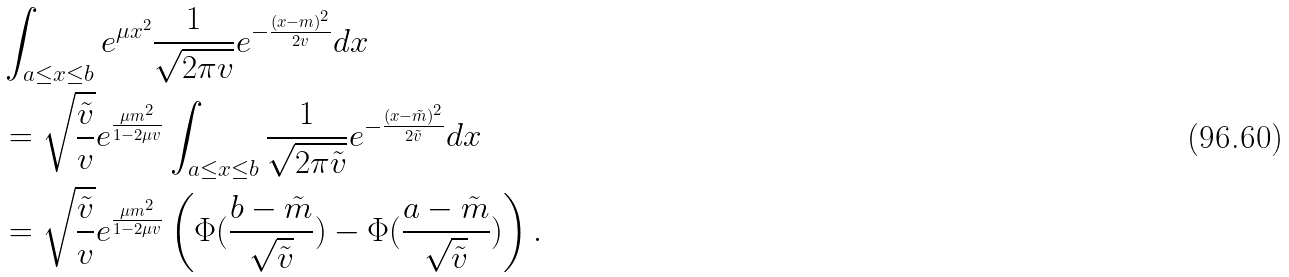Convert formula to latex. <formula><loc_0><loc_0><loc_500><loc_500>& \int _ { a \leq x \leq b } e ^ { \mu x ^ { 2 } } \frac { 1 } { \sqrt { 2 \pi v } } e ^ { - \frac { ( x - m ) ^ { 2 } } { 2 v } } d x \\ & = \sqrt { \frac { \tilde { v } } { v } } e ^ { \frac { \mu m ^ { 2 } } { 1 - 2 \mu v } } \int _ { a \leq x \leq b } \frac { 1 } { \sqrt { 2 \pi \tilde { v } } } e ^ { - \frac { ( x - \tilde { m } ) ^ { 2 } } { 2 \tilde { v } } } d x \\ & = \sqrt { \frac { \tilde { v } } { v } } e ^ { \frac { \mu m ^ { 2 } } { 1 - 2 \mu v } } \left ( \Phi ( \frac { b - \tilde { m } } { \sqrt { \tilde { v } } } ) - \Phi ( \frac { a - \tilde { m } } { \sqrt { \tilde { v } } } ) \right ) .</formula> 